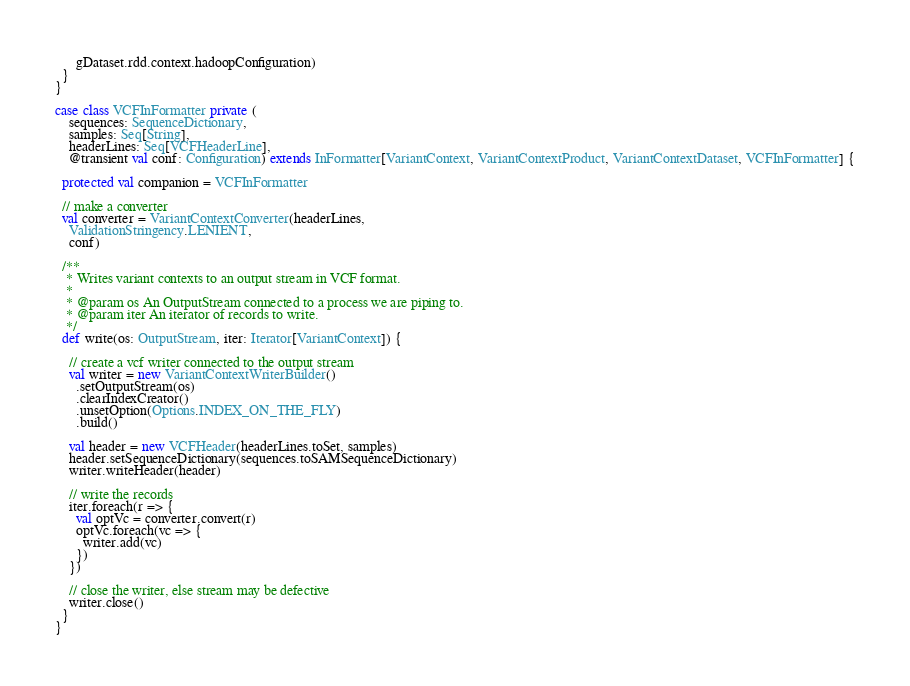<code> <loc_0><loc_0><loc_500><loc_500><_Scala_>      gDataset.rdd.context.hadoopConfiguration)
  }
}

case class VCFInFormatter private (
    sequences: SequenceDictionary,
    samples: Seq[String],
    headerLines: Seq[VCFHeaderLine],
    @transient val conf: Configuration) extends InFormatter[VariantContext, VariantContextProduct, VariantContextDataset, VCFInFormatter] {

  protected val companion = VCFInFormatter

  // make a converter
  val converter = VariantContextConverter(headerLines,
    ValidationStringency.LENIENT,
    conf)

  /**
   * Writes variant contexts to an output stream in VCF format.
   *
   * @param os An OutputStream connected to a process we are piping to.
   * @param iter An iterator of records to write.
   */
  def write(os: OutputStream, iter: Iterator[VariantContext]) {

    // create a vcf writer connected to the output stream
    val writer = new VariantContextWriterBuilder()
      .setOutputStream(os)
      .clearIndexCreator()
      .unsetOption(Options.INDEX_ON_THE_FLY)
      .build()

    val header = new VCFHeader(headerLines.toSet, samples)
    header.setSequenceDictionary(sequences.toSAMSequenceDictionary)
    writer.writeHeader(header)

    // write the records
    iter.foreach(r => {
      val optVc = converter.convert(r)
      optVc.foreach(vc => {
        writer.add(vc)
      })
    })

    // close the writer, else stream may be defective
    writer.close()
  }
}
</code> 